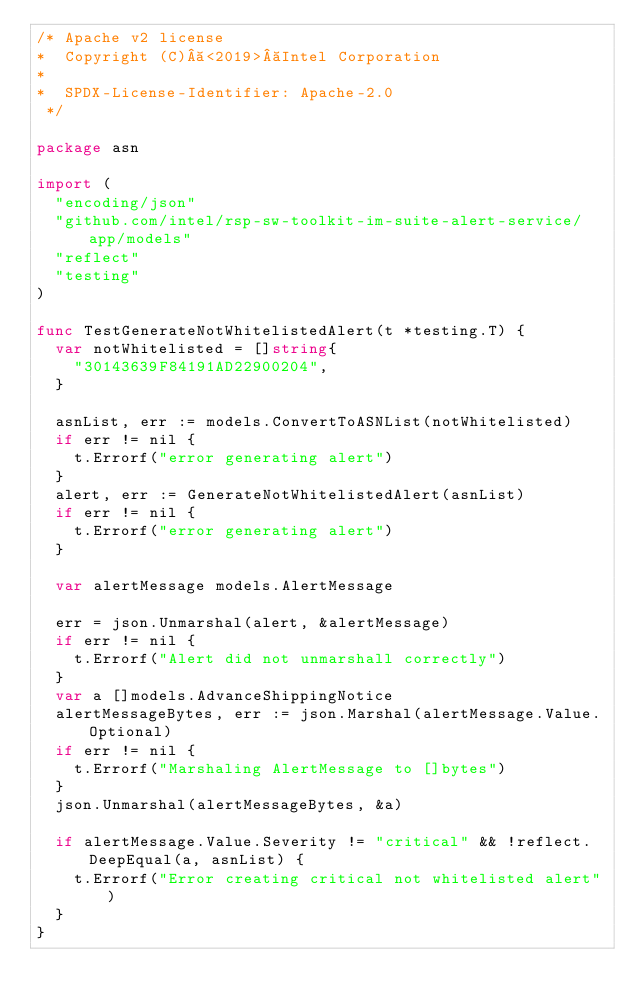Convert code to text. <code><loc_0><loc_0><loc_500><loc_500><_Go_>/* Apache v2 license
*  Copyright (C) <2019> Intel Corporation
*
*  SPDX-License-Identifier: Apache-2.0
 */

package asn

import (
	"encoding/json"
	"github.com/intel/rsp-sw-toolkit-im-suite-alert-service/app/models"
	"reflect"
	"testing"
)

func TestGenerateNotWhitelistedAlert(t *testing.T) {
	var notWhitelisted = []string{
		"30143639F84191AD22900204",
	}

	asnList, err := models.ConvertToASNList(notWhitelisted)
	if err != nil {
		t.Errorf("error generating alert")
	}
	alert, err := GenerateNotWhitelistedAlert(asnList)
	if err != nil {
		t.Errorf("error generating alert")
	}

	var alertMessage models.AlertMessage

	err = json.Unmarshal(alert, &alertMessage)
	if err != nil {
		t.Errorf("Alert did not unmarshall correctly")
	}
	var a []models.AdvanceShippingNotice
	alertMessageBytes, err := json.Marshal(alertMessage.Value.Optional)
	if err != nil {
		t.Errorf("Marshaling AlertMessage to []bytes")
	}
	json.Unmarshal(alertMessageBytes, &a)

	if alertMessage.Value.Severity != "critical" && !reflect.DeepEqual(a, asnList) {
		t.Errorf("Error creating critical not whitelisted alert")
	}
}
</code> 